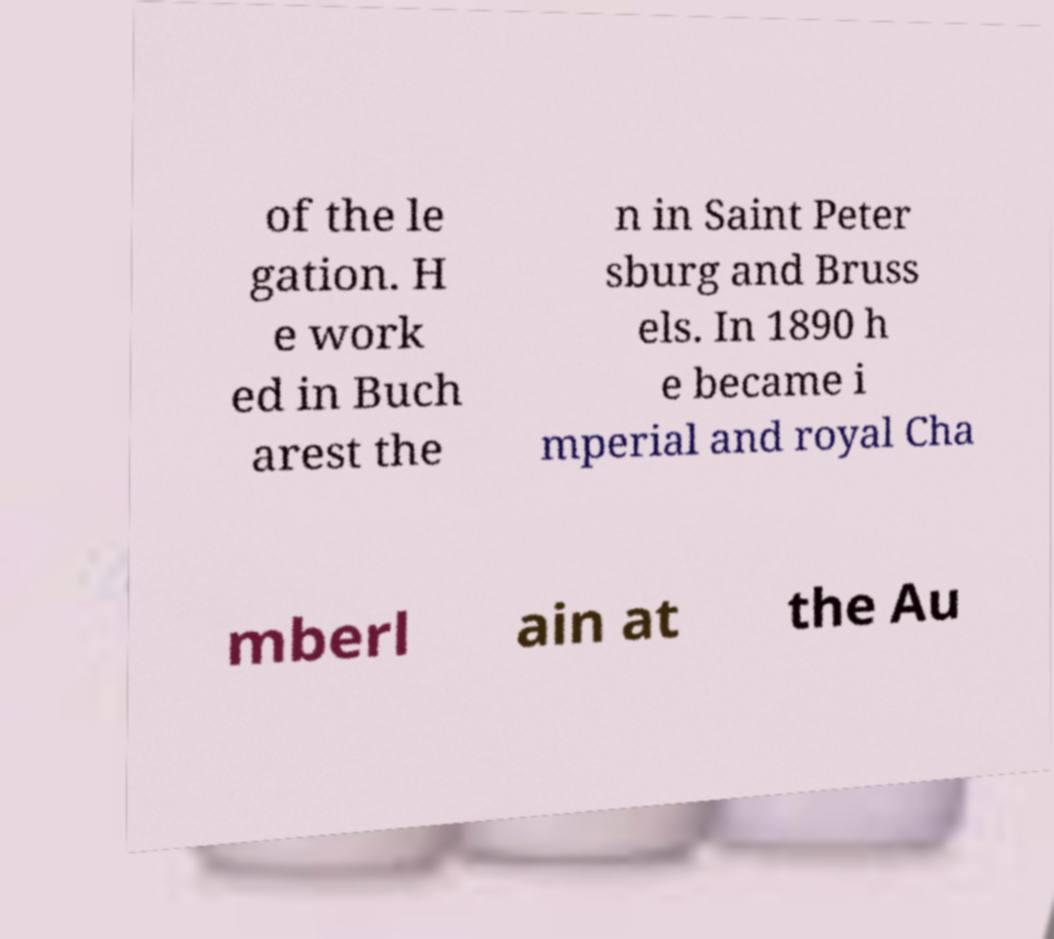For documentation purposes, I need the text within this image transcribed. Could you provide that? of the le gation. H e work ed in Buch arest the n in Saint Peter sburg and Bruss els. In 1890 h e became i mperial and royal Cha mberl ain at the Au 